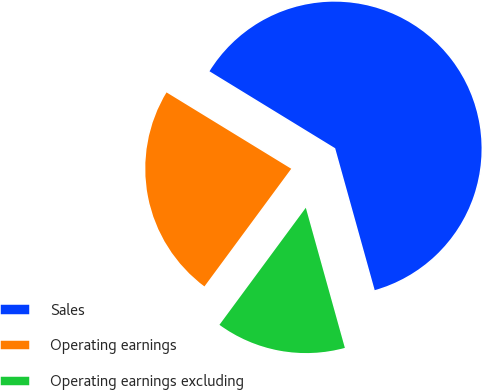Convert chart. <chart><loc_0><loc_0><loc_500><loc_500><pie_chart><fcel>Sales<fcel>Operating earnings<fcel>Operating earnings excluding<nl><fcel>61.93%<fcel>23.63%<fcel>14.44%<nl></chart> 